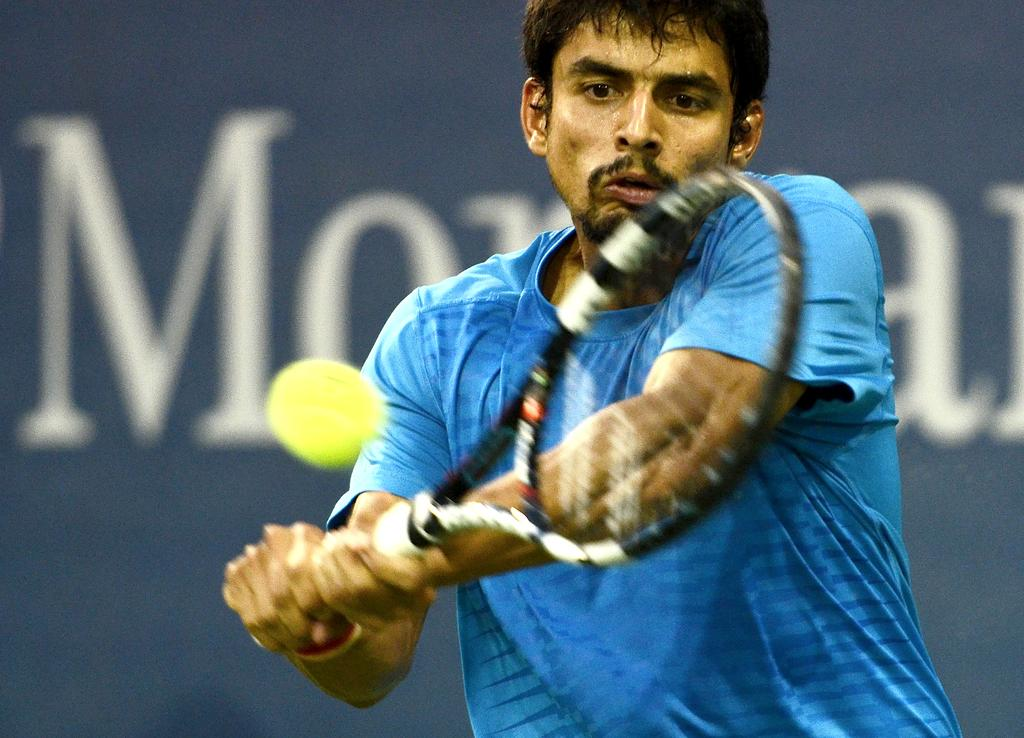Who is present in the image? There is a man in the image. What is the man holding in the image? The man is holding a bat. What is the man doing with the bat? The man is hitting a ball. What color is the man's t-shirt? The man is wearing a blue t-shirt. What can be seen in the background of the image? There is text visible in the background of the image. What flavor of duck is being served in the image? There are no ducks or references to food in the image, so it is not possible to determine the flavor of any duck. 